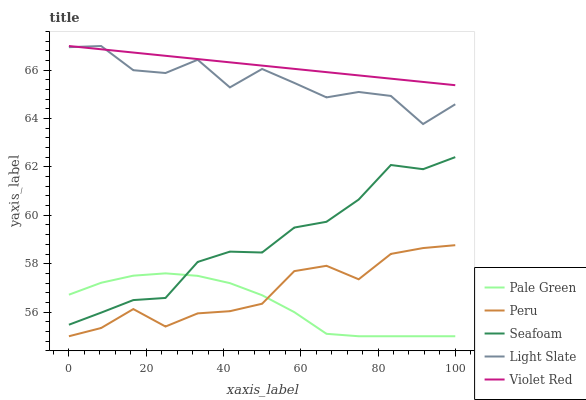Does Pale Green have the minimum area under the curve?
Answer yes or no. Yes. Does Violet Red have the maximum area under the curve?
Answer yes or no. Yes. Does Violet Red have the minimum area under the curve?
Answer yes or no. No. Does Pale Green have the maximum area under the curve?
Answer yes or no. No. Is Violet Red the smoothest?
Answer yes or no. Yes. Is Light Slate the roughest?
Answer yes or no. Yes. Is Pale Green the smoothest?
Answer yes or no. No. Is Pale Green the roughest?
Answer yes or no. No. Does Pale Green have the lowest value?
Answer yes or no. Yes. Does Violet Red have the lowest value?
Answer yes or no. No. Does Violet Red have the highest value?
Answer yes or no. Yes. Does Pale Green have the highest value?
Answer yes or no. No. Is Seafoam less than Violet Red?
Answer yes or no. Yes. Is Light Slate greater than Peru?
Answer yes or no. Yes. Does Light Slate intersect Violet Red?
Answer yes or no. Yes. Is Light Slate less than Violet Red?
Answer yes or no. No. Is Light Slate greater than Violet Red?
Answer yes or no. No. Does Seafoam intersect Violet Red?
Answer yes or no. No. 